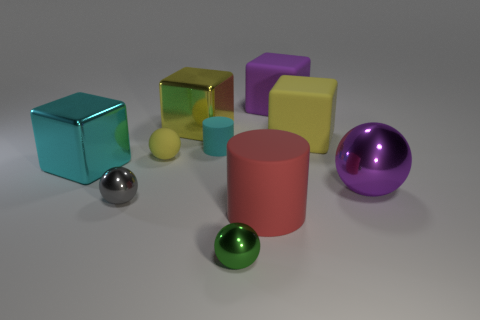Subtract 1 balls. How many balls are left? 3 Subtract all cylinders. How many objects are left? 8 Subtract 1 yellow balls. How many objects are left? 9 Subtract all big blue matte balls. Subtract all shiny blocks. How many objects are left? 8 Add 2 tiny matte cylinders. How many tiny matte cylinders are left? 3 Add 8 cyan matte cylinders. How many cyan matte cylinders exist? 9 